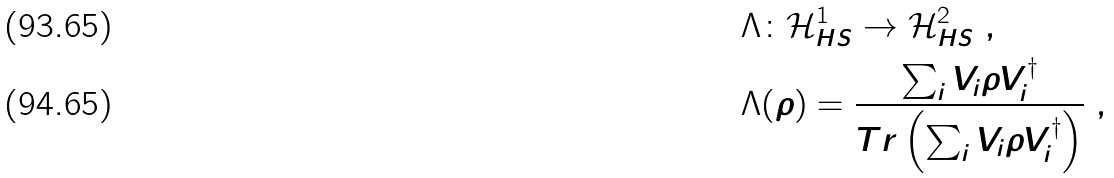Convert formula to latex. <formula><loc_0><loc_0><loc_500><loc_500>& \Lambda \colon \mathcal { H } ^ { 1 } _ { H S } \rightarrow \mathcal { H } ^ { 2 } _ { H S } \ , \\ & \Lambda ( \rho ) = \frac { \sum _ { i } V _ { i } \rho V _ { i } ^ { \dagger } } { T r \left ( \sum _ { i } V _ { i } \rho V _ { i } ^ { \dagger } \right ) } \ ,</formula> 